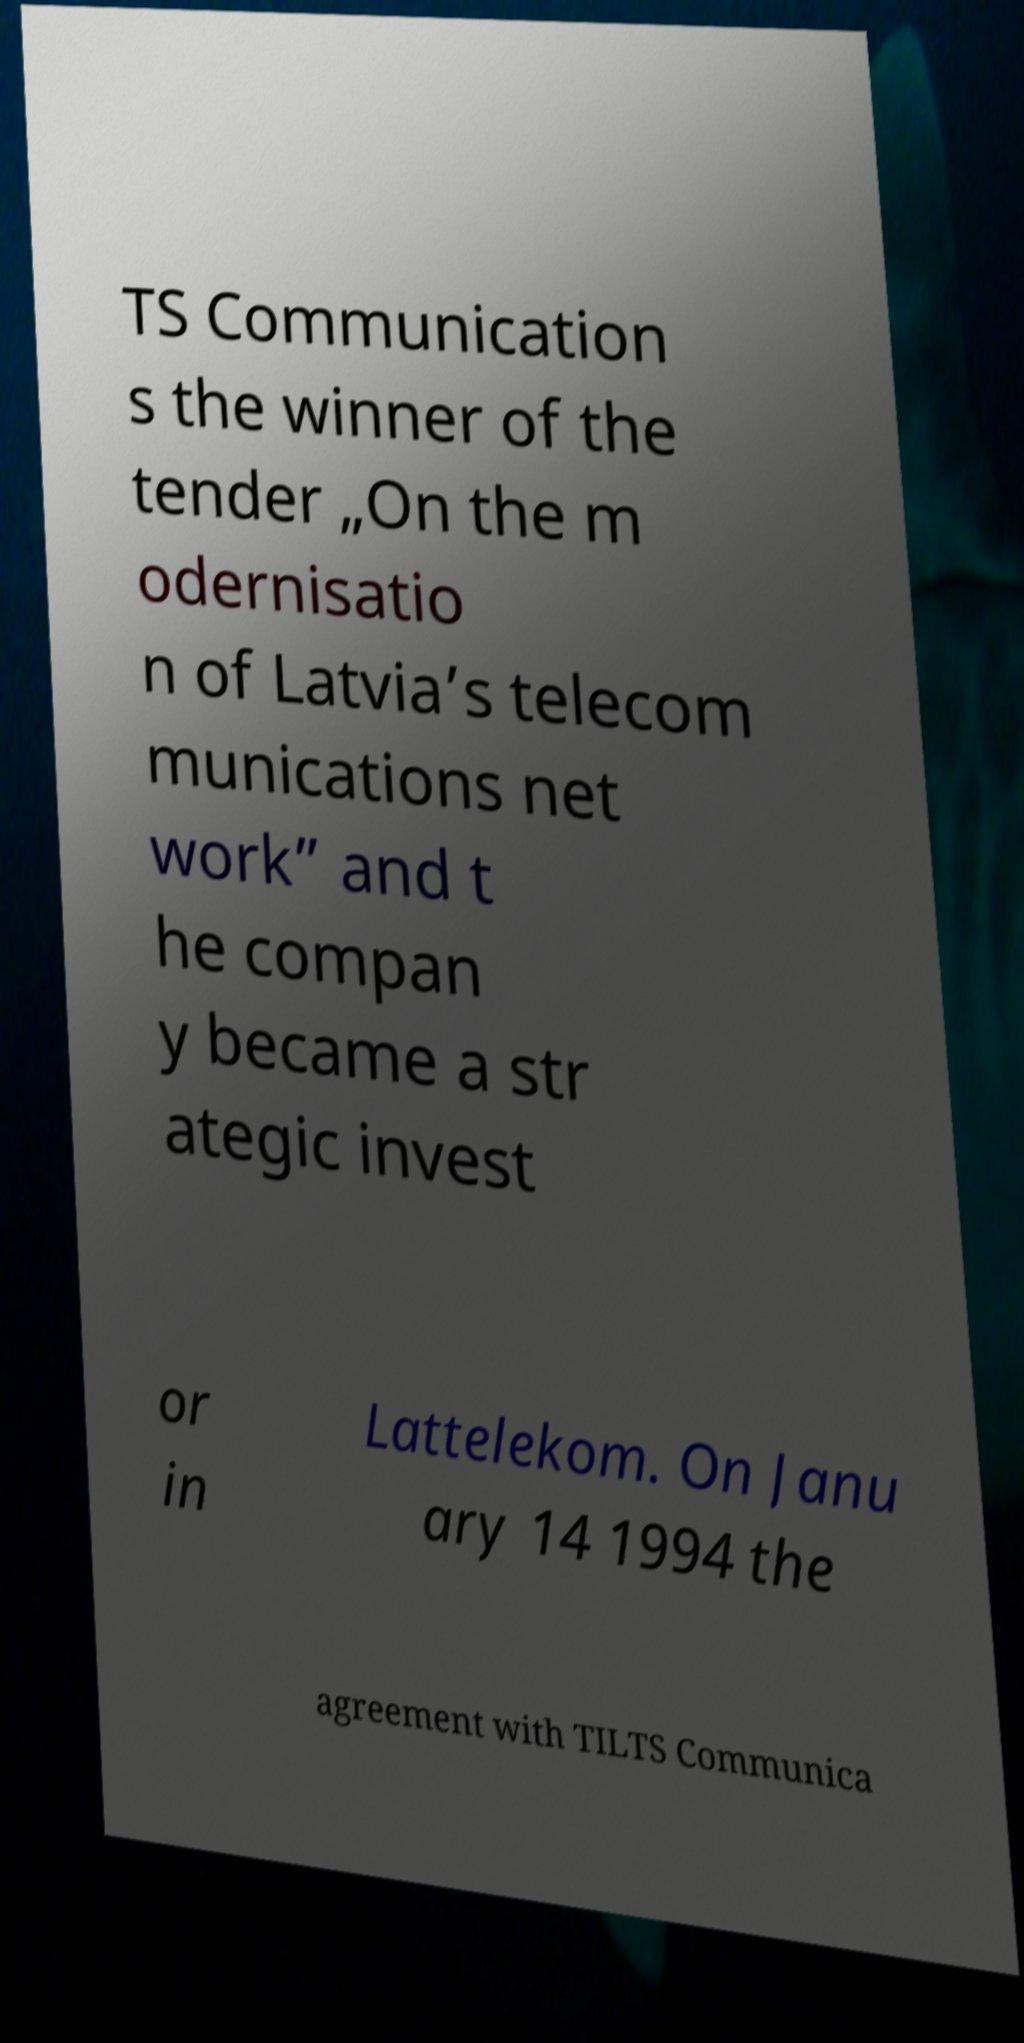What messages or text are displayed in this image? I need them in a readable, typed format. TS Communication s the winner of the tender „On the m odernisatio n of Latvia’s telecom munications net work” and t he compan y became a str ategic invest or in Lattelekom. On Janu ary 14 1994 the agreement with TILTS Communica 